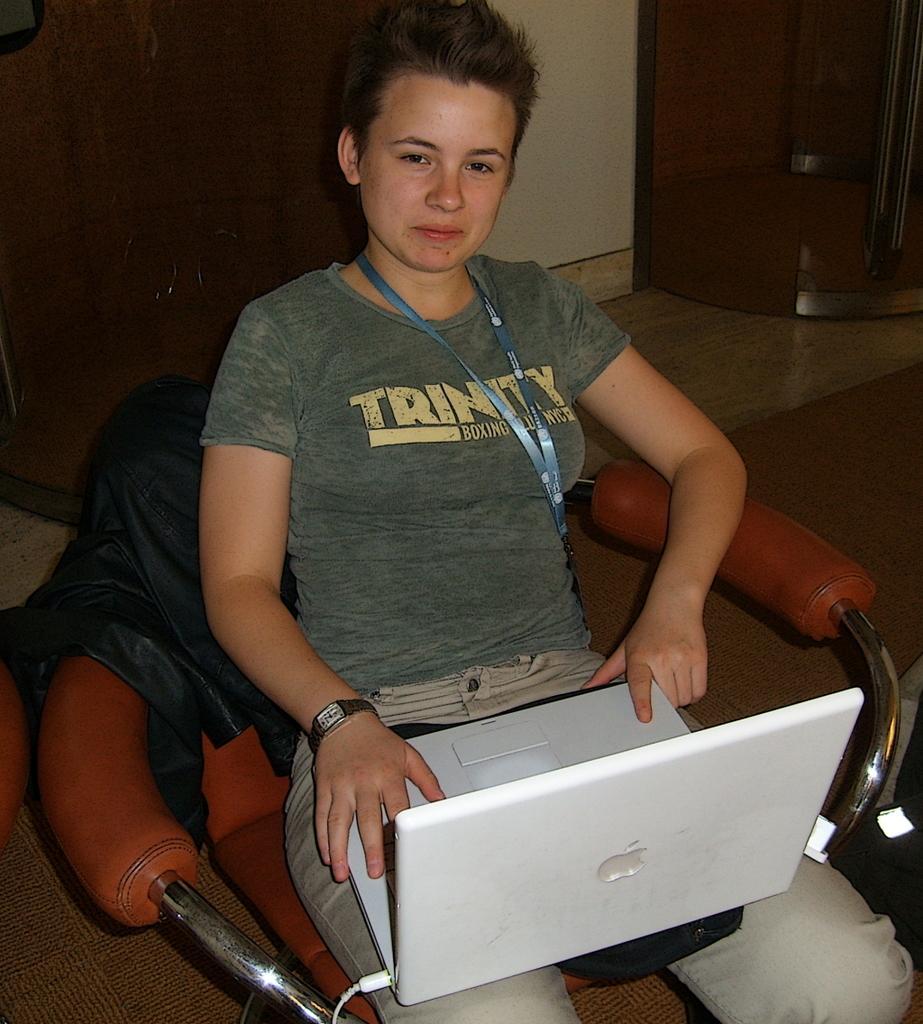In one or two sentences, can you explain what this image depicts? In this image we can see a person sitting on the chair holding a laptop on her lap. In the background we can see walls and floor. 